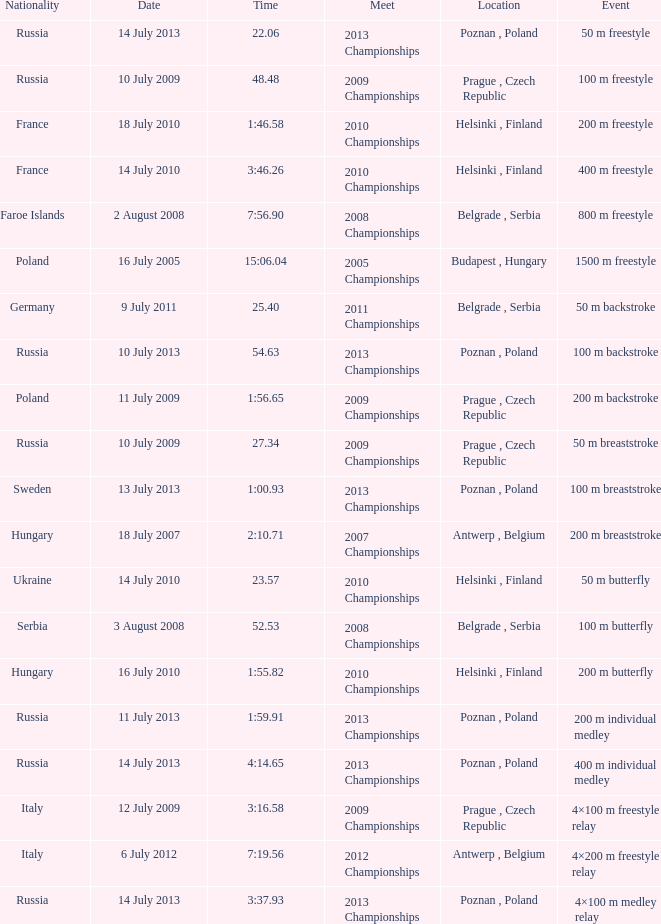Where were the 2008 championships with a time of 7:56.90 held? Belgrade , Serbia. 